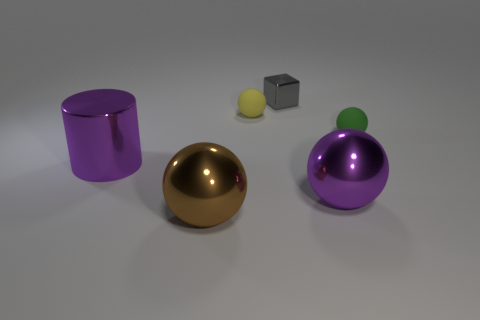What material is the green object that is the same shape as the small yellow thing?
Offer a terse response. Rubber. Are there any green balls that are left of the shiny object to the left of the large brown metal sphere in front of the small yellow thing?
Give a very brief answer. No. How many other things are there of the same color as the big cylinder?
Provide a succinct answer. 1. How many shiny things are in front of the tiny green ball and right of the small yellow sphere?
Provide a short and direct response. 1. What shape is the green thing?
Your answer should be very brief. Sphere. How many other objects are the same material as the tiny green thing?
Your response must be concise. 1. The rubber object that is behind the tiny rubber thing right of the rubber sphere behind the green ball is what color?
Provide a short and direct response. Yellow. There is a yellow object that is the same size as the block; what is it made of?
Provide a succinct answer. Rubber. How many objects are purple shiny objects on the left side of the gray block or brown metallic objects?
Offer a very short reply. 2. Are there any purple things?
Make the answer very short. Yes. 